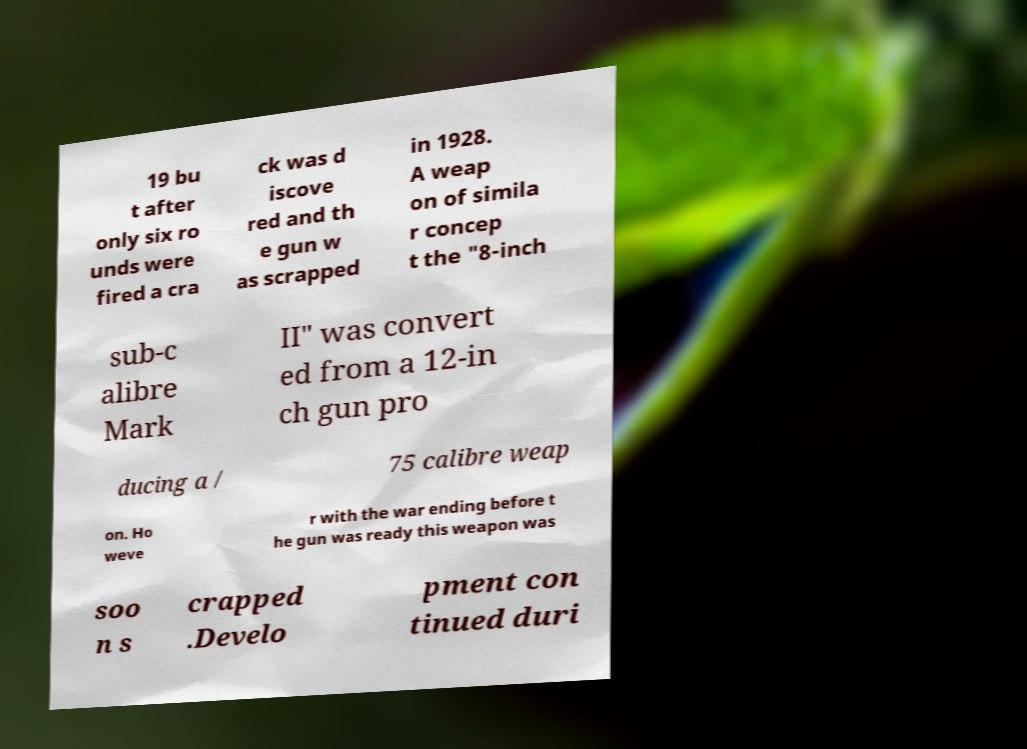Can you read and provide the text displayed in the image?This photo seems to have some interesting text. Can you extract and type it out for me? 19 bu t after only six ro unds were fired a cra ck was d iscove red and th e gun w as scrapped in 1928. A weap on of simila r concep t the "8-inch sub-c alibre Mark II" was convert ed from a 12-in ch gun pro ducing a / 75 calibre weap on. Ho weve r with the war ending before t he gun was ready this weapon was soo n s crapped .Develo pment con tinued duri 